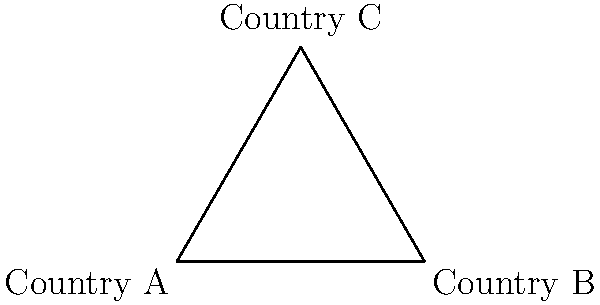The diagram represents the missile defense coverage of three countries (A, B, and C) in a region. The circles indicate the range of each country's missile defense systems. Based on this information, which country is most vulnerable to a potential missile attack, and how does this affect the geopolitical power balance in the region? To determine the most vulnerable country and its impact on geopolitical power balance, let's analyze the diagram step-by-step:

1. Coverage analysis:
   - Country A: 40 km radius
   - Country B: 60 km radius
   - Country C: 50 km radius

2. Overlap assessment:
   - There is significant overlap between the defense systems of all three countries.
   - The center of each country is covered by at least one other country's defense system.

3. Vulnerability evaluation:
   - Country A has the smallest coverage radius (40 km).
   - A larger portion of Country A's territory is outside its own defense range compared to B and C.
   - Countries B and C have partial coverage of A's territory, but there are still gaps.

4. Geopolitical implications:
   - Country A is the most vulnerable due to its smaller defense radius and gaps in coverage.
   - This vulnerability could lead to A seeking stronger alliances with B and/or C for protection.
   - A might also invest more in expanding its missile defense capabilities to address this weakness.
   - Countries B and C have a strategic advantage over A, potentially influencing regional politics and negotiations.

5. Power balance:
   - The overlapping defense systems create a complex interdependence among the three countries.
   - While A is more vulnerable, the shared coverage suggests a need for cooperation in regional security.
   - B and C may have more leverage in diplomatic and military discussions due to their superior defense capabilities.

In conclusion, Country A is the most vulnerable, which shifts the geopolitical power balance in favor of Countries B and C. This situation likely influences regional alliances, military spending, and diplomatic negotiations.
Answer: Country A; shifts power to B and C, encourages alliances and defense investment. 